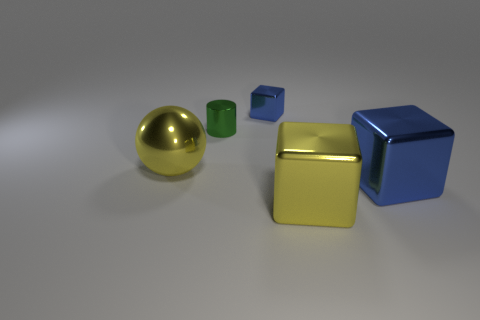Add 3 small blue rubber things. How many objects exist? 8 Subtract all blocks. How many objects are left? 2 Add 1 big yellow shiny balls. How many big yellow shiny balls are left? 2 Add 3 gray spheres. How many gray spheres exist? 3 Subtract 0 cyan cubes. How many objects are left? 5 Subtract all big objects. Subtract all big yellow things. How many objects are left? 0 